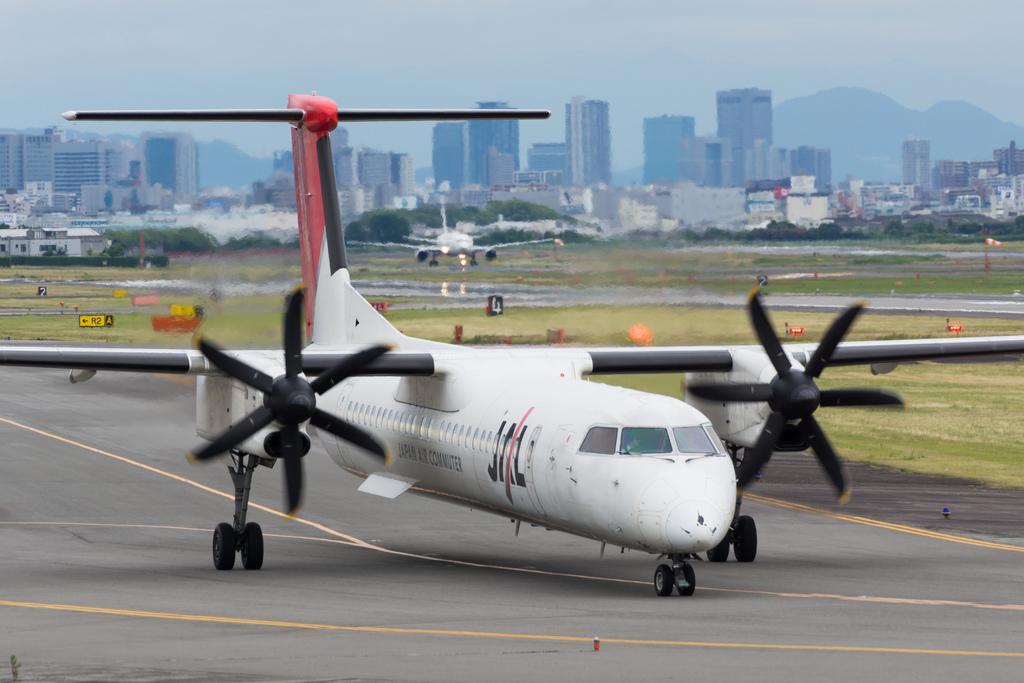How would you summarize this image in a sentence or two? In the picture we can see an aircraft on the runway and behind it, we can see the grass surface and far away from it, we can see other aircraft and in the background we can see the trees, buildings, hill and the sky. 